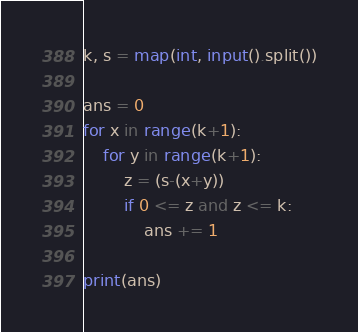<code> <loc_0><loc_0><loc_500><loc_500><_Python_>k, s = map(int, input().split())

ans = 0
for x in range(k+1):
    for y in range(k+1):
        z = (s-(x+y))
        if 0 <= z and z <= k:
            ans += 1 

print(ans)</code> 